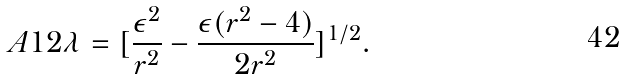Convert formula to latex. <formula><loc_0><loc_0><loc_500><loc_500>A 1 2 \lambda = [ \frac { \epsilon ^ { 2 } } { r ^ { 2 } } - \frac { \epsilon ( r ^ { 2 } - 4 ) } { 2 r ^ { 2 } } ] ^ { 1 / 2 } .</formula> 